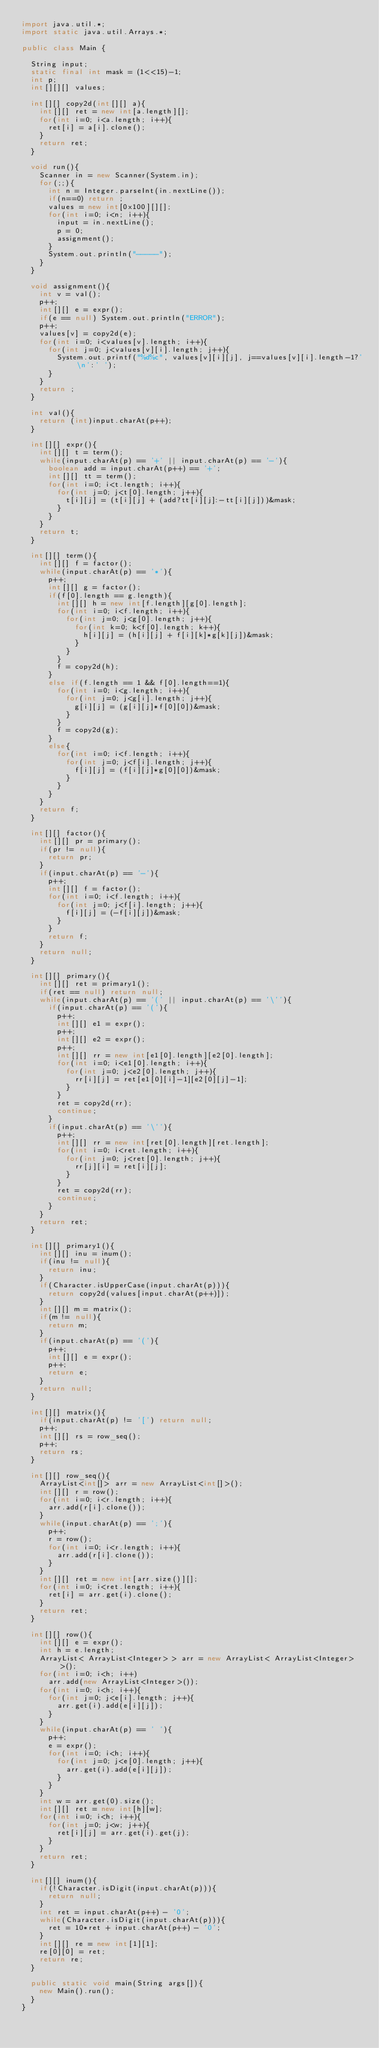<code> <loc_0><loc_0><loc_500><loc_500><_Java_>import java.util.*;
import static java.util.Arrays.*;

public class Main {

	String input;
	static final int mask = (1<<15)-1;
	int p;
	int[][][] values;
	
	int[][] copy2d(int[][] a){
		int[][] ret = new int[a.length][];
		for(int i=0; i<a.length; i++){
			ret[i] = a[i].clone();
		}
		return ret;
	}
	
	void run(){
		Scanner in = new Scanner(System.in);
		for(;;){
			int n = Integer.parseInt(in.nextLine());
			if(n==0) return ;
			values = new int[0x100][][];
			for(int i=0; i<n; i++){
				input = in.nextLine();
				p = 0;
				assignment();
			}
			System.out.println("-----");
		}
	}

	void assignment(){
		int v = val();
		p++;
		int[][] e = expr();
		if(e == null) System.out.println("ERROR");
		p++;
		values[v] = copy2d(e);
		for(int i=0; i<values[v].length; i++){
			for(int j=0; j<values[v][i].length; j++){
				System.out.printf("%d%c", values[v][i][j], j==values[v][i].length-1?'\n':' ');
			}
		}
		return ;
	}
	
	int val(){
		return (int)input.charAt(p++);
	}

	int[][] expr(){
		int[][] t = term();
		while(input.charAt(p) == '+' || input.charAt(p) == '-'){
			boolean add = input.charAt(p++) == '+';
			int[][] tt = term();
			for(int i=0; i<t.length; i++){
				for(int j=0; j<t[0].length; j++){
					t[i][j] = (t[i][j] + (add?tt[i][j]:-tt[i][j]))&mask;
				}
			}
		}
		return t;
	}
	
	int[][] term(){
		int[][] f = factor();
		while(input.charAt(p) == '*'){
			p++;
			int[][] g = factor();
			if(f[0].length == g.length){
				int[][] h = new int[f.length][g[0].length];
				for(int i=0; i<f.length; i++){
					for(int j=0; j<g[0].length; j++){
						for(int k=0; k<f[0].length; k++){
							h[i][j] = (h[i][j] + f[i][k]*g[k][j])&mask;
						}
					}
				}
				f = copy2d(h);
			}
			else if(f.length == 1 && f[0].length==1){
				for(int i=0; i<g.length; i++){
					for(int j=0; j<g[i].length; j++){
						g[i][j] = (g[i][j]*f[0][0])&mask;
					}
				}
				f = copy2d(g);
			}
			else{
				for(int i=0; i<f.length; i++){
					for(int j=0; j<f[i].length; j++){
						f[i][j] = (f[i][j]*g[0][0])&mask;
					}
				}
			}
		}
		return f;
	}

	int[][] factor(){
		int[][] pr = primary();
		if(pr != null){
			return pr;
		}
		if(input.charAt(p) == '-'){
			p++;
			int[][] f = factor();
			for(int i=0; i<f.length; i++){
				for(int j=0; j<f[i].length; j++){
					f[i][j] = (-f[i][j])&mask;
				}
			}
			return f;
		}
		return null;
	}

	int[][] primary(){
		int[][] ret = primary1();
		if(ret == null) return null;
		while(input.charAt(p) == '(' || input.charAt(p) == '\''){
			if(input.charAt(p) == '('){
				p++;
				int[][] e1 = expr();
				p++;
				int[][] e2 = expr();
				p++;
				int[][] rr = new int[e1[0].length][e2[0].length];
				for(int i=0; i<e1[0].length; i++){
					for(int j=0; j<e2[0].length; j++){
						rr[i][j] = ret[e1[0][i]-1][e2[0][j]-1];
					}
				}
				ret = copy2d(rr);
				continue;
			}
			if(input.charAt(p) == '\''){
				p++;
				int[][] rr = new int[ret[0].length][ret.length];
				for(int i=0; i<ret.length; i++){
					for(int j=0; j<ret[0].length; j++){
						rr[j][i] = ret[i][j];
					}
				}
				ret = copy2d(rr);
				continue;
			}
		}
		return ret;
	}

	int[][] primary1(){
		int[][] inu = inum();
		if(inu != null){
			return inu;
		}
		if(Character.isUpperCase(input.charAt(p))){
			return copy2d(values[input.charAt(p++)]);
		}
		int[][] m = matrix();
		if(m != null){
			return m;
		}
		if(input.charAt(p) == '('){
			p++;
			int[][] e = expr();
			p++;
			return e;
		}
		return null;
	}

	int[][] matrix(){
		if(input.charAt(p) != '[') return null;
		p++;
		int[][] rs = row_seq();
		p++;
		return rs;
	}

	int[][] row_seq(){
		ArrayList<int[]> arr = new ArrayList<int[]>();
		int[][] r = row();
		for(int i=0; i<r.length; i++){
			arr.add(r[i].clone());
		}
		while(input.charAt(p) == ';'){
			p++;
			r = row();
			for(int i=0; i<r.length; i++){
				arr.add(r[i].clone());
			}
		}
		int[][] ret = new int[arr.size()][];
		for(int i=0; i<ret.length; i++){
			ret[i] = arr.get(i).clone();
		}
		return ret;
	}

	int[][] row(){
		int[][] e = expr();
		int h = e.length;
		ArrayList< ArrayList<Integer> > arr = new ArrayList< ArrayList<Integer> >();
		for(int i=0; i<h; i++)
			arr.add(new ArrayList<Integer>());
		for(int i=0; i<h; i++){
			for(int j=0; j<e[i].length; j++){
				arr.get(i).add(e[i][j]);
			}
		}
		while(input.charAt(p) == ' '){
			p++;
			e = expr();
			for(int i=0; i<h; i++){
				for(int j=0; j<e[0].length; j++){
					arr.get(i).add(e[i][j]);
				}
			}
		}
		int w = arr.get(0).size();
		int[][] ret = new int[h][w];
		for(int i=0; i<h; i++){
			for(int j=0; j<w; j++){
				ret[i][j] = arr.get(i).get(j);
			}
		}
		return ret;
	}

	int[][] inum(){
		if(!Character.isDigit(input.charAt(p))){
			return null;
		}
		int ret = input.charAt(p++) - '0';
		while(Character.isDigit(input.charAt(p))){
			ret = 10*ret + input.charAt(p++) - '0';
		}
		int[][] re = new int[1][1];
		re[0][0] = ret;
		return re;
	}

	public static void main(String args[]){
		new Main().run();
	}
}</code> 